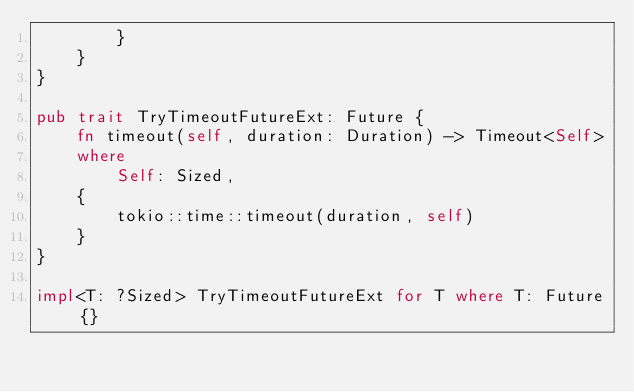<code> <loc_0><loc_0><loc_500><loc_500><_Rust_>        }
    }
}

pub trait TryTimeoutFutureExt: Future {
    fn timeout(self, duration: Duration) -> Timeout<Self>
    where
        Self: Sized,
    {
        tokio::time::timeout(duration, self)
    }
}

impl<T: ?Sized> TryTimeoutFutureExt for T where T: Future {}
</code> 